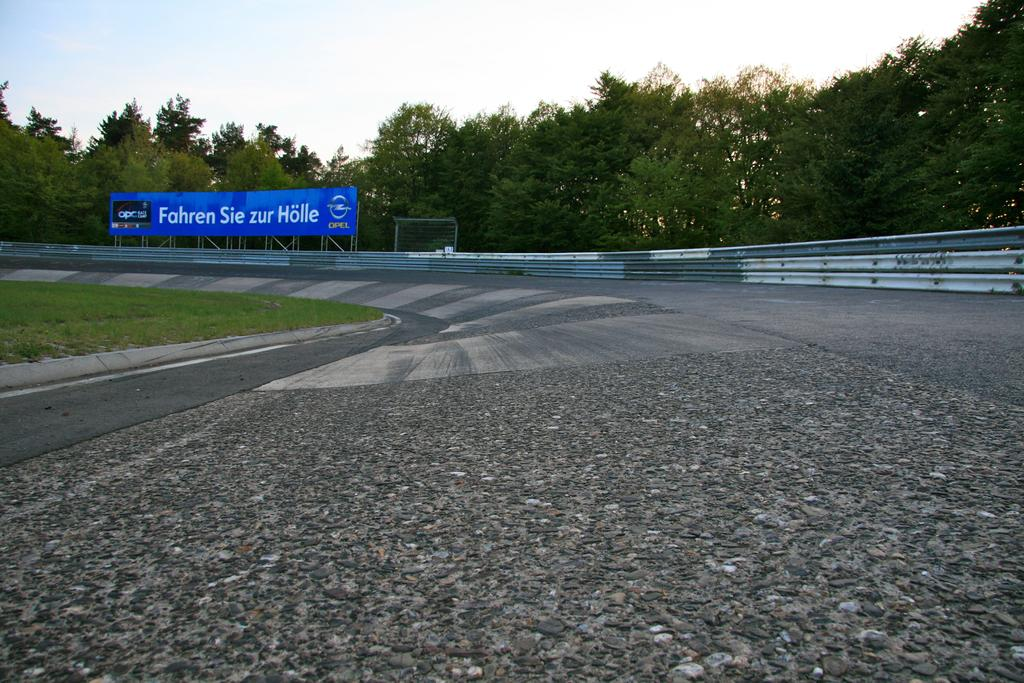<image>
Relay a brief, clear account of the picture shown. A billboard from OPEL sits over a car racing track. 